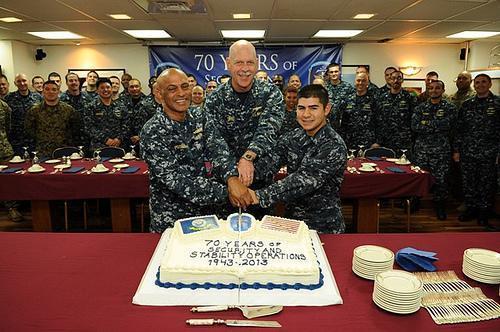How many people are cutting the cake?
Give a very brief answer. 3. How many stacks of plates next to the cake are shown?
Give a very brief answer. 3. 